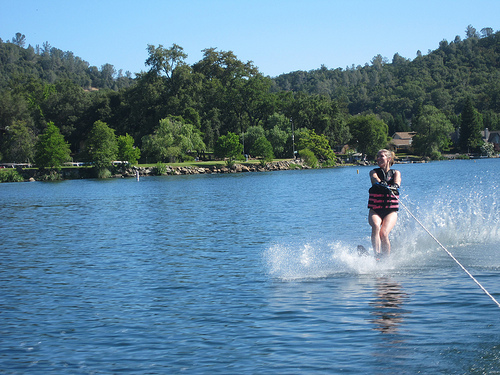How many people are there? There is one person visible in the image, actively engaged in water skiing. 